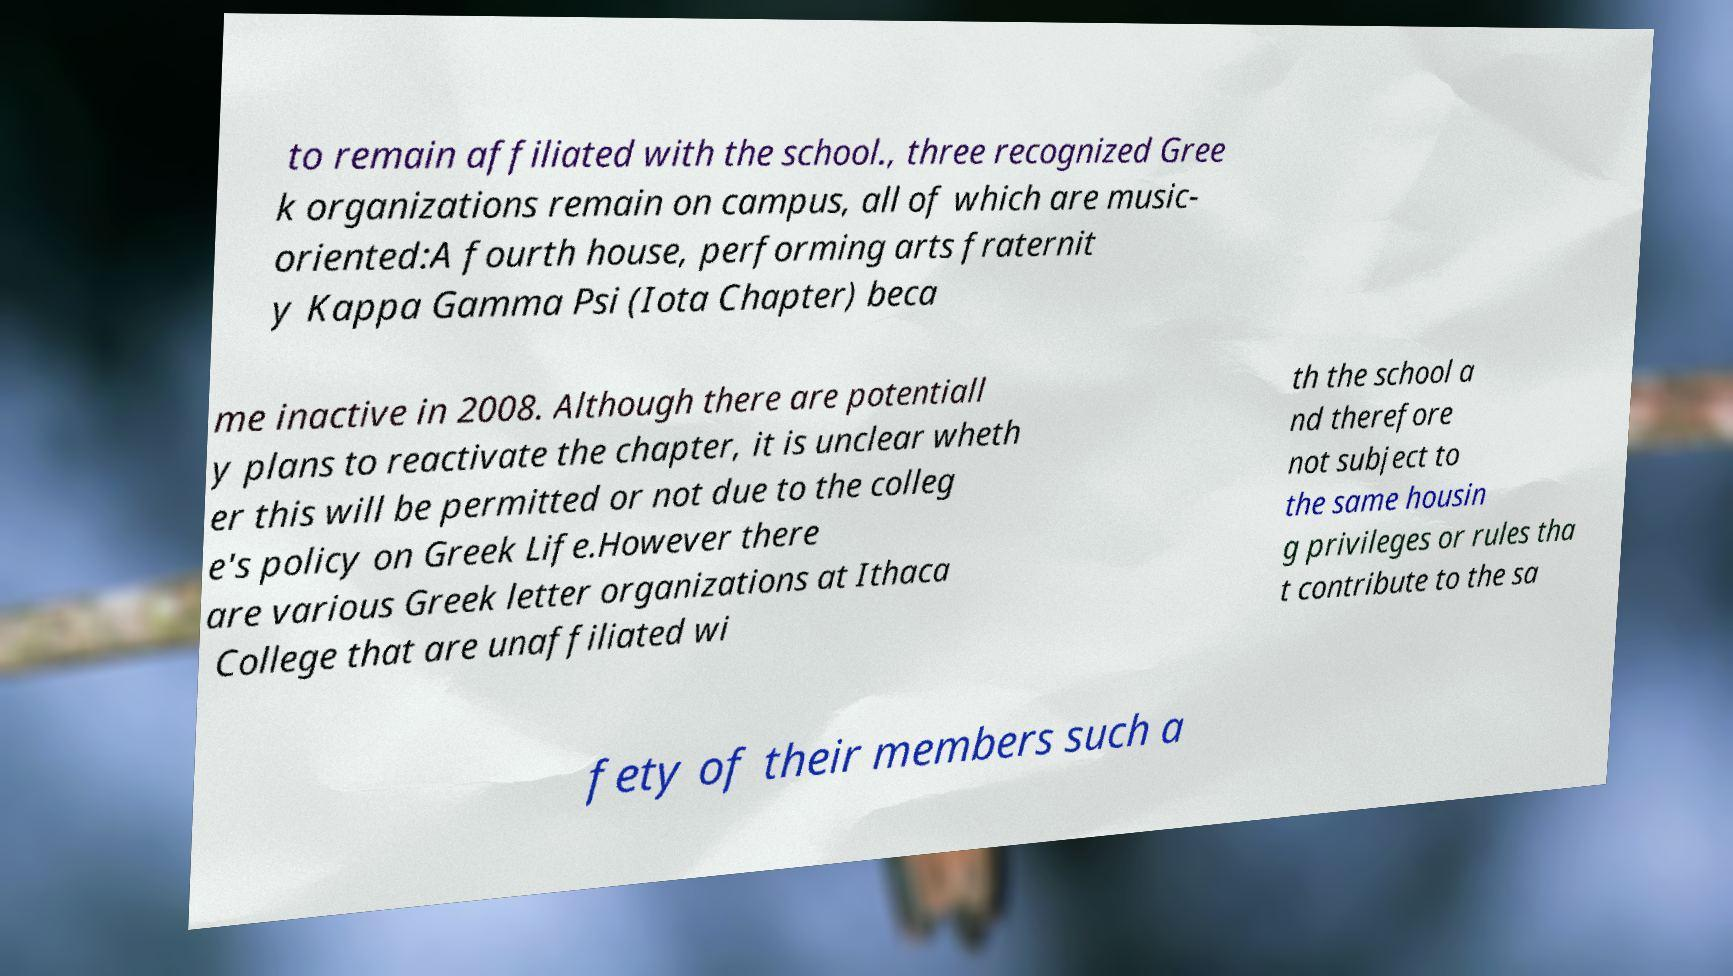Can you accurately transcribe the text from the provided image for me? to remain affiliated with the school., three recognized Gree k organizations remain on campus, all of which are music- oriented:A fourth house, performing arts fraternit y Kappa Gamma Psi (Iota Chapter) beca me inactive in 2008. Although there are potentiall y plans to reactivate the chapter, it is unclear wheth er this will be permitted or not due to the colleg e's policy on Greek Life.However there are various Greek letter organizations at Ithaca College that are unaffiliated wi th the school a nd therefore not subject to the same housin g privileges or rules tha t contribute to the sa fety of their members such a 